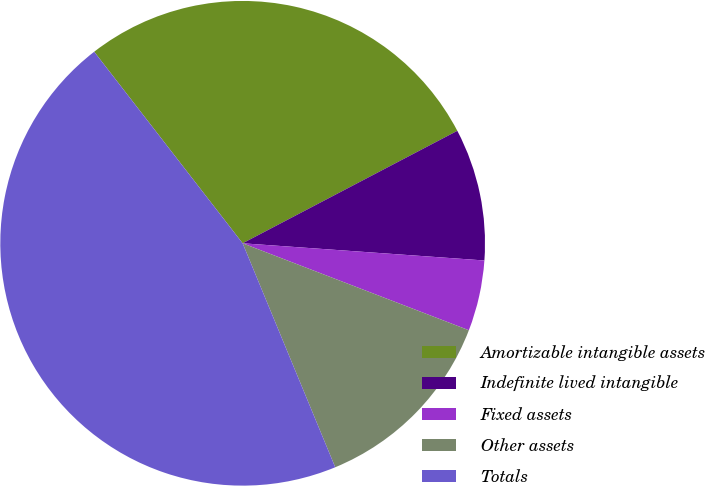Convert chart. <chart><loc_0><loc_0><loc_500><loc_500><pie_chart><fcel>Amortizable intangible assets<fcel>Indefinite lived intangible<fcel>Fixed assets<fcel>Other assets<fcel>Totals<nl><fcel>27.81%<fcel>8.81%<fcel>4.71%<fcel>12.92%<fcel>45.74%<nl></chart> 